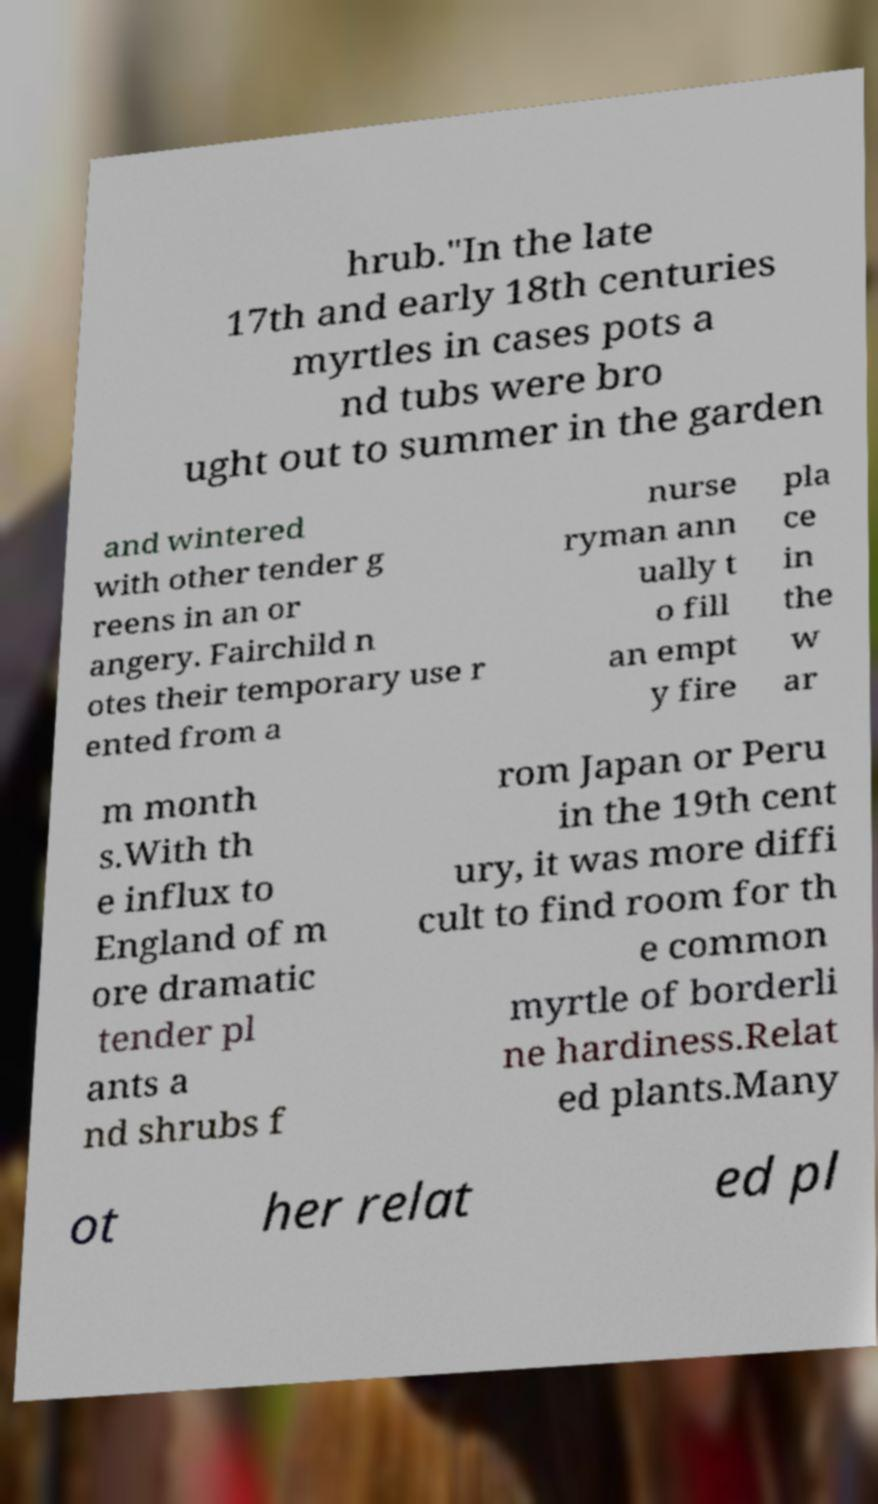Can you read and provide the text displayed in the image?This photo seems to have some interesting text. Can you extract and type it out for me? hrub."In the late 17th and early 18th centuries myrtles in cases pots a nd tubs were bro ught out to summer in the garden and wintered with other tender g reens in an or angery. Fairchild n otes their temporary use r ented from a nurse ryman ann ually t o fill an empt y fire pla ce in the w ar m month s.With th e influx to England of m ore dramatic tender pl ants a nd shrubs f rom Japan or Peru in the 19th cent ury, it was more diffi cult to find room for th e common myrtle of borderli ne hardiness.Relat ed plants.Many ot her relat ed pl 